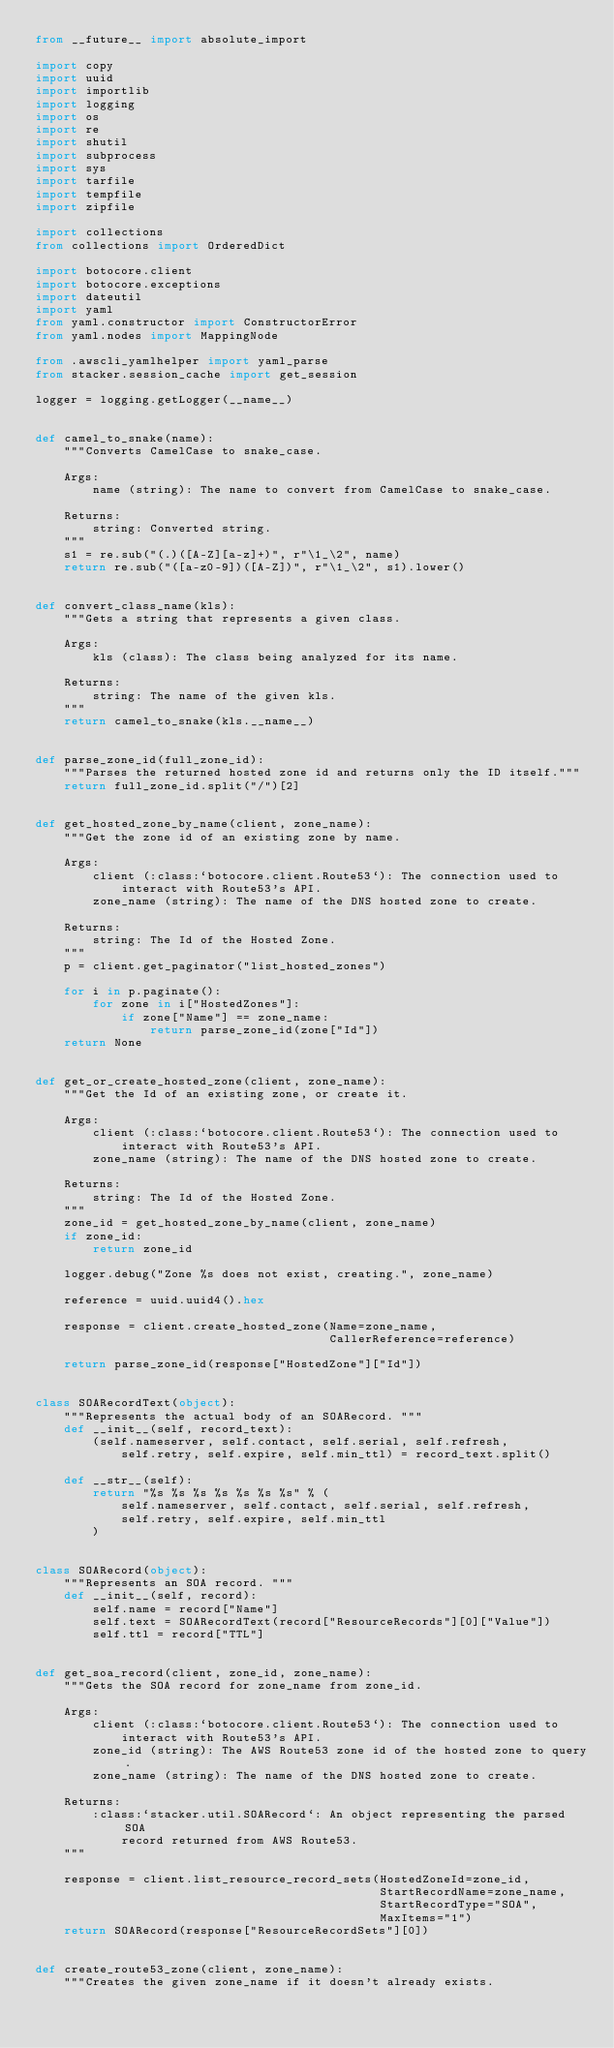Convert code to text. <code><loc_0><loc_0><loc_500><loc_500><_Python_>from __future__ import absolute_import

import copy
import uuid
import importlib
import logging
import os
import re
import shutil
import subprocess
import sys
import tarfile
import tempfile
import zipfile

import collections
from collections import OrderedDict

import botocore.client
import botocore.exceptions
import dateutil
import yaml
from yaml.constructor import ConstructorError
from yaml.nodes import MappingNode

from .awscli_yamlhelper import yaml_parse
from stacker.session_cache import get_session

logger = logging.getLogger(__name__)


def camel_to_snake(name):
    """Converts CamelCase to snake_case.

    Args:
        name (string): The name to convert from CamelCase to snake_case.

    Returns:
        string: Converted string.
    """
    s1 = re.sub("(.)([A-Z][a-z]+)", r"\1_\2", name)
    return re.sub("([a-z0-9])([A-Z])", r"\1_\2", s1).lower()


def convert_class_name(kls):
    """Gets a string that represents a given class.

    Args:
        kls (class): The class being analyzed for its name.

    Returns:
        string: The name of the given kls.
    """
    return camel_to_snake(kls.__name__)


def parse_zone_id(full_zone_id):
    """Parses the returned hosted zone id and returns only the ID itself."""
    return full_zone_id.split("/")[2]


def get_hosted_zone_by_name(client, zone_name):
    """Get the zone id of an existing zone by name.

    Args:
        client (:class:`botocore.client.Route53`): The connection used to
            interact with Route53's API.
        zone_name (string): The name of the DNS hosted zone to create.

    Returns:
        string: The Id of the Hosted Zone.
    """
    p = client.get_paginator("list_hosted_zones")

    for i in p.paginate():
        for zone in i["HostedZones"]:
            if zone["Name"] == zone_name:
                return parse_zone_id(zone["Id"])
    return None


def get_or_create_hosted_zone(client, zone_name):
    """Get the Id of an existing zone, or create it.

    Args:
        client (:class:`botocore.client.Route53`): The connection used to
            interact with Route53's API.
        zone_name (string): The name of the DNS hosted zone to create.

    Returns:
        string: The Id of the Hosted Zone.
    """
    zone_id = get_hosted_zone_by_name(client, zone_name)
    if zone_id:
        return zone_id

    logger.debug("Zone %s does not exist, creating.", zone_name)

    reference = uuid.uuid4().hex

    response = client.create_hosted_zone(Name=zone_name,
                                         CallerReference=reference)

    return parse_zone_id(response["HostedZone"]["Id"])


class SOARecordText(object):
    """Represents the actual body of an SOARecord. """
    def __init__(self, record_text):
        (self.nameserver, self.contact, self.serial, self.refresh,
            self.retry, self.expire, self.min_ttl) = record_text.split()

    def __str__(self):
        return "%s %s %s %s %s %s %s" % (
            self.nameserver, self.contact, self.serial, self.refresh,
            self.retry, self.expire, self.min_ttl
        )


class SOARecord(object):
    """Represents an SOA record. """
    def __init__(self, record):
        self.name = record["Name"]
        self.text = SOARecordText(record["ResourceRecords"][0]["Value"])
        self.ttl = record["TTL"]


def get_soa_record(client, zone_id, zone_name):
    """Gets the SOA record for zone_name from zone_id.

    Args:
        client (:class:`botocore.client.Route53`): The connection used to
            interact with Route53's API.
        zone_id (string): The AWS Route53 zone id of the hosted zone to query.
        zone_name (string): The name of the DNS hosted zone to create.

    Returns:
        :class:`stacker.util.SOARecord`: An object representing the parsed SOA
            record returned from AWS Route53.
    """

    response = client.list_resource_record_sets(HostedZoneId=zone_id,
                                                StartRecordName=zone_name,
                                                StartRecordType="SOA",
                                                MaxItems="1")
    return SOARecord(response["ResourceRecordSets"][0])


def create_route53_zone(client, zone_name):
    """Creates the given zone_name if it doesn't already exists.
</code> 